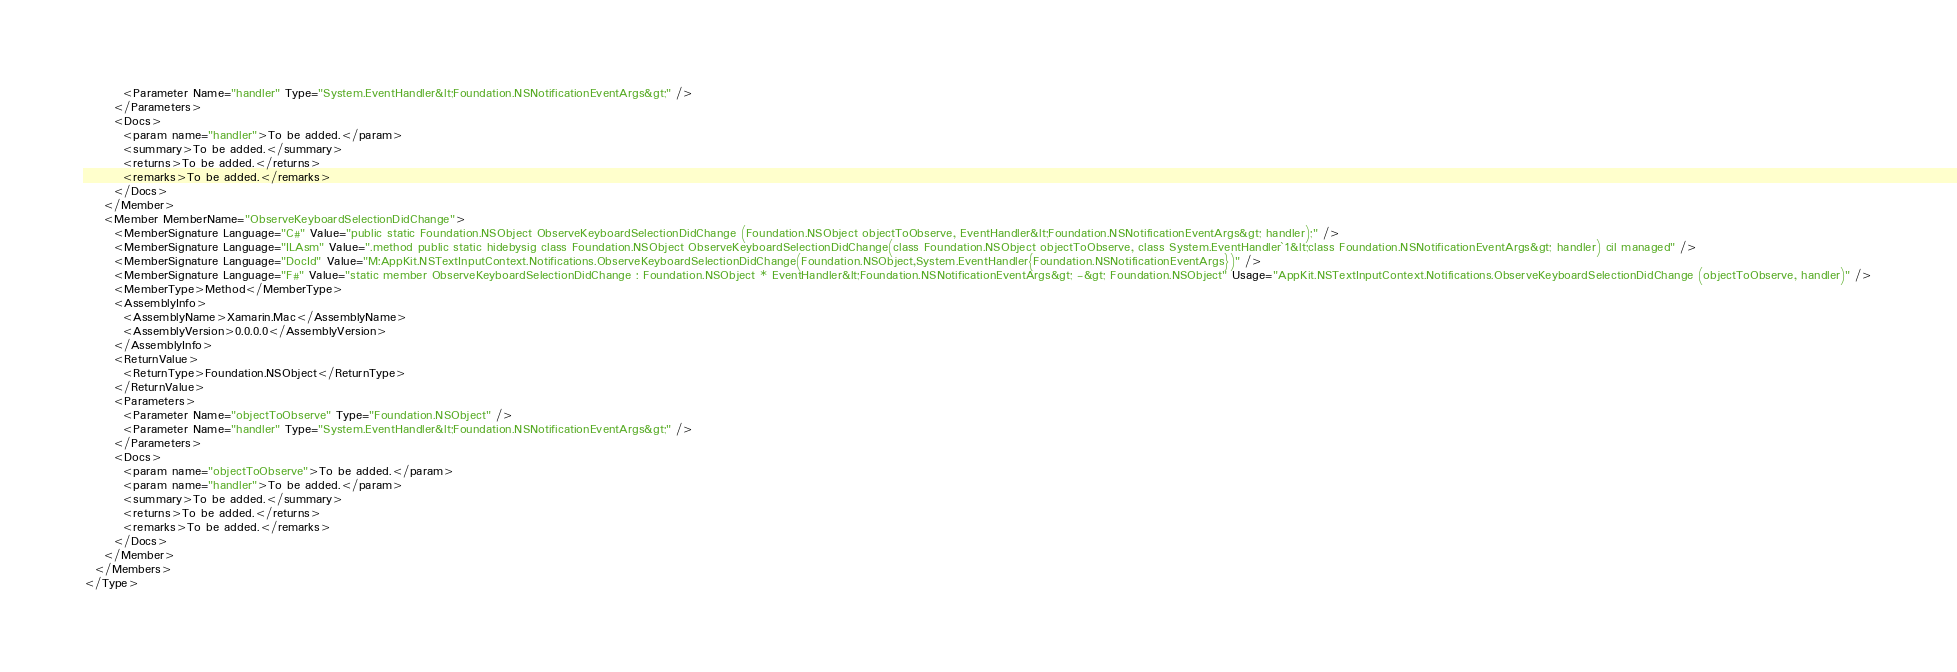Convert code to text. <code><loc_0><loc_0><loc_500><loc_500><_XML_>        <Parameter Name="handler" Type="System.EventHandler&lt;Foundation.NSNotificationEventArgs&gt;" />
      </Parameters>
      <Docs>
        <param name="handler">To be added.</param>
        <summary>To be added.</summary>
        <returns>To be added.</returns>
        <remarks>To be added.</remarks>
      </Docs>
    </Member>
    <Member MemberName="ObserveKeyboardSelectionDidChange">
      <MemberSignature Language="C#" Value="public static Foundation.NSObject ObserveKeyboardSelectionDidChange (Foundation.NSObject objectToObserve, EventHandler&lt;Foundation.NSNotificationEventArgs&gt; handler);" />
      <MemberSignature Language="ILAsm" Value=".method public static hidebysig class Foundation.NSObject ObserveKeyboardSelectionDidChange(class Foundation.NSObject objectToObserve, class System.EventHandler`1&lt;class Foundation.NSNotificationEventArgs&gt; handler) cil managed" />
      <MemberSignature Language="DocId" Value="M:AppKit.NSTextInputContext.Notifications.ObserveKeyboardSelectionDidChange(Foundation.NSObject,System.EventHandler{Foundation.NSNotificationEventArgs})" />
      <MemberSignature Language="F#" Value="static member ObserveKeyboardSelectionDidChange : Foundation.NSObject * EventHandler&lt;Foundation.NSNotificationEventArgs&gt; -&gt; Foundation.NSObject" Usage="AppKit.NSTextInputContext.Notifications.ObserveKeyboardSelectionDidChange (objectToObserve, handler)" />
      <MemberType>Method</MemberType>
      <AssemblyInfo>
        <AssemblyName>Xamarin.Mac</AssemblyName>
        <AssemblyVersion>0.0.0.0</AssemblyVersion>
      </AssemblyInfo>
      <ReturnValue>
        <ReturnType>Foundation.NSObject</ReturnType>
      </ReturnValue>
      <Parameters>
        <Parameter Name="objectToObserve" Type="Foundation.NSObject" />
        <Parameter Name="handler" Type="System.EventHandler&lt;Foundation.NSNotificationEventArgs&gt;" />
      </Parameters>
      <Docs>
        <param name="objectToObserve">To be added.</param>
        <param name="handler">To be added.</param>
        <summary>To be added.</summary>
        <returns>To be added.</returns>
        <remarks>To be added.</remarks>
      </Docs>
    </Member>
  </Members>
</Type>
</code> 